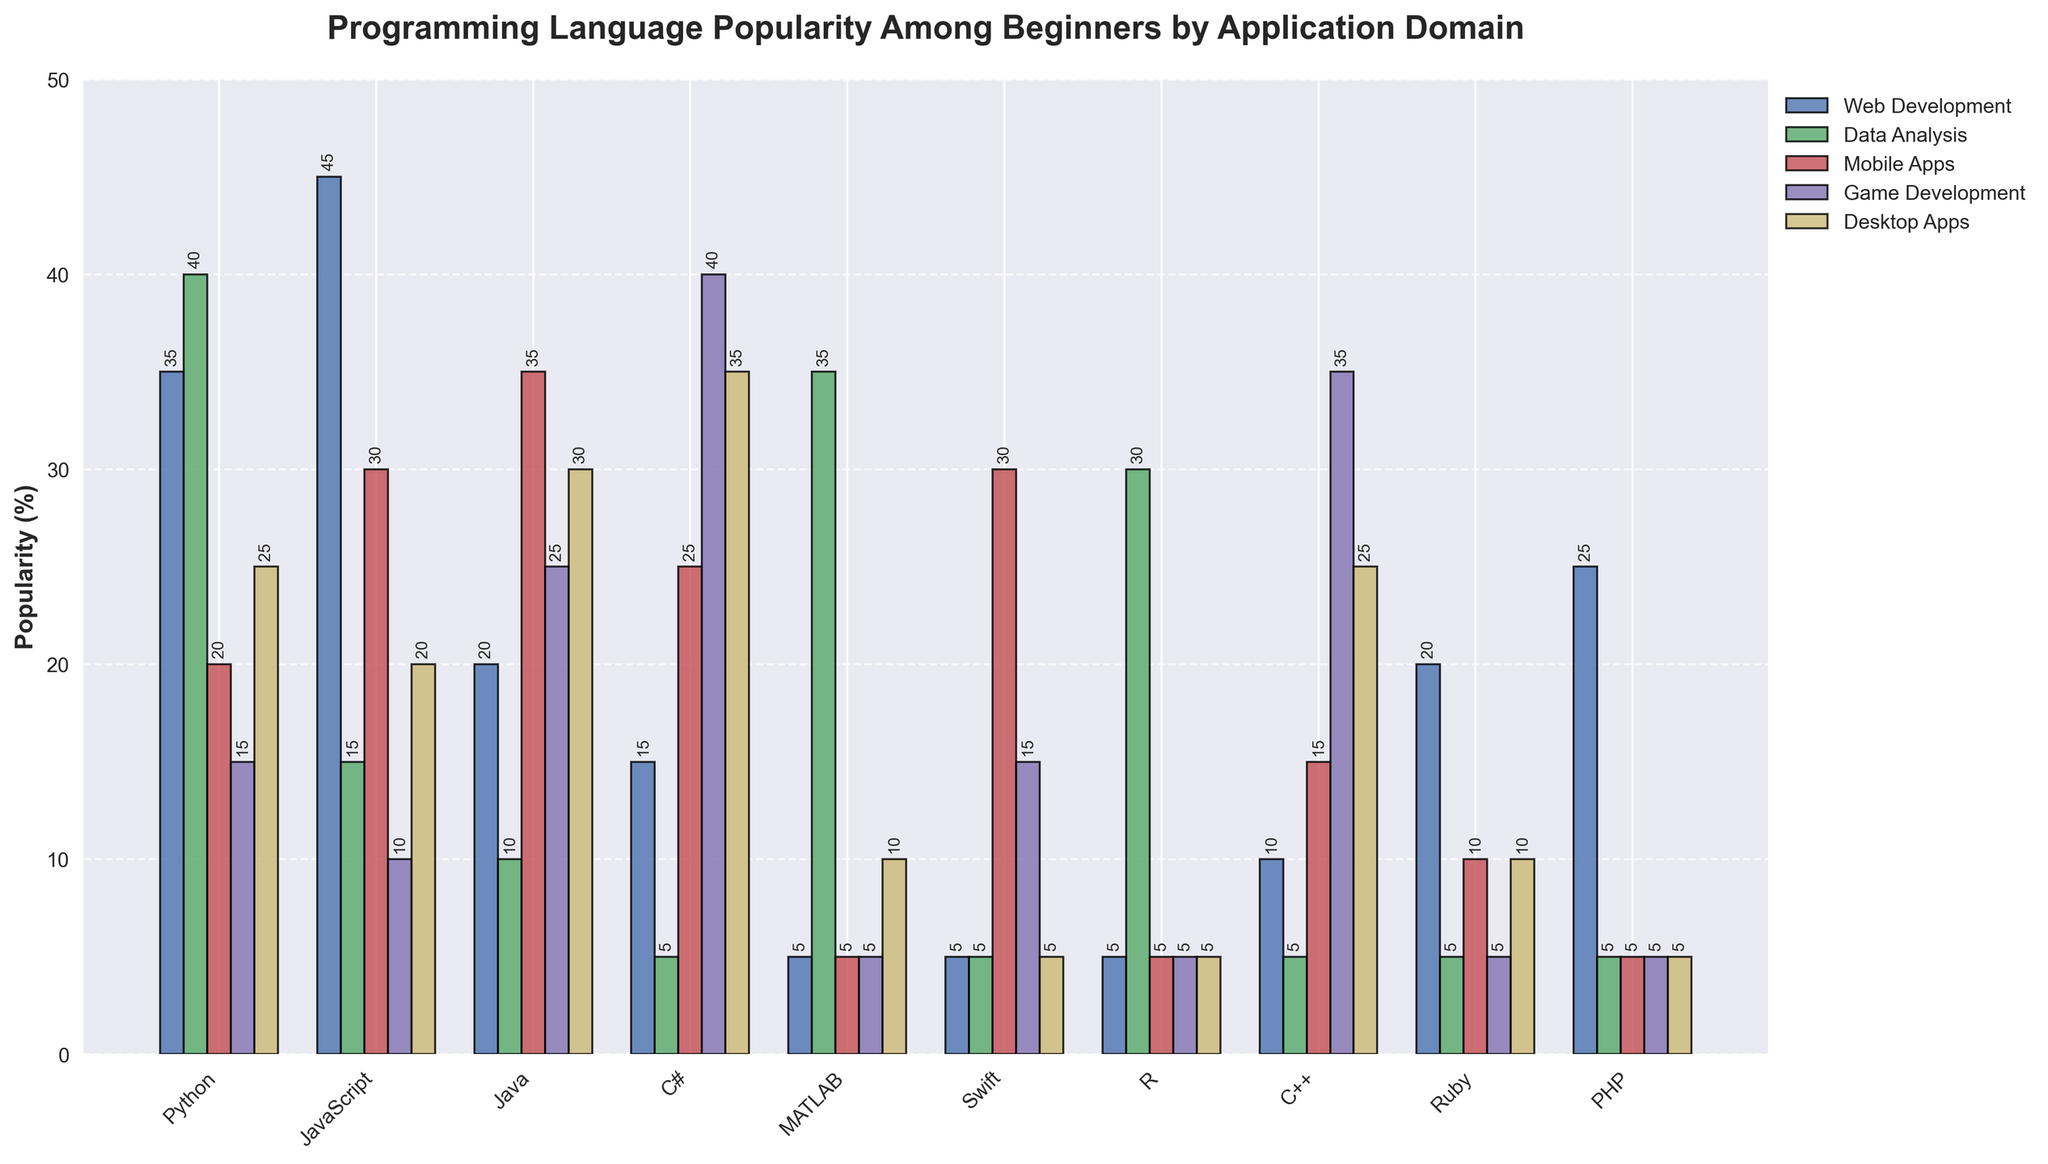Which programming language is most popular for Web Development? When looking at the bars for Web Development, JavaScript has the highest bar compared to other languages.
Answer: JavaScript Out of Python and C#, which is more popular for Game Development? Check the heights of the bars for Python and C# under Game Development. C# has a higher bar at 40%, while Python's is at 15%.
Answer: C# What is the combined popularity of Python and MATLAB for Data Analysis? For Data Analysis, the bar heights for Python and MATLAB are 40% and 35%, respectively. Adding these together gives 40% + 35% = 75%.
Answer: 75% Which application domain does Java have the highest popularity? For Java, observe all the application domains, and the highest bar is for Mobile Apps at 35%.
Answer: Mobile Apps Which language has the lowest popularity for Desktop Apps, and what is its value? Check the bar heights under Desktop Apps and find the smallest one. It's Swift with a bar height of 5%.
Answer: Swift, 5% How much more popular is C++ for Game Development compared to Mobile Apps? For C++, the bar height for Game Development is 35%, and for Mobile Apps, it's 15%. The difference is 35% - 15% = 20%.
Answer: 20% Which languages have the same popularity for Data Analysis, and what is the percentage? For Data Analysis, both MATLAB and R have bars at 35% and 30% respectively.
Answer: None, there is no equality What is the average popularity of JavaScript across all application domains? JavaScript has popularity values of 45%, 15%, 30%, 10%, and 20%. The sum is 120%, and the average is 120% / 5 = 24%.
Answer: 24% Among all the languages, which has the highest popularity for one application domain, and what is that domain? After comparing the highest bars across all languages and domains, JavaScript for Web Development at 45% is the highest.
Answer: JavaScript, Web Development Which language has the smallest total popularity across all domains, and what is that total? Sum the values for each language, and find the smallest total. PHP's total is 25%, calculated as 25% + 5% + 5% + 5% + 5% = 45%.
Answer: PHP, 45% 